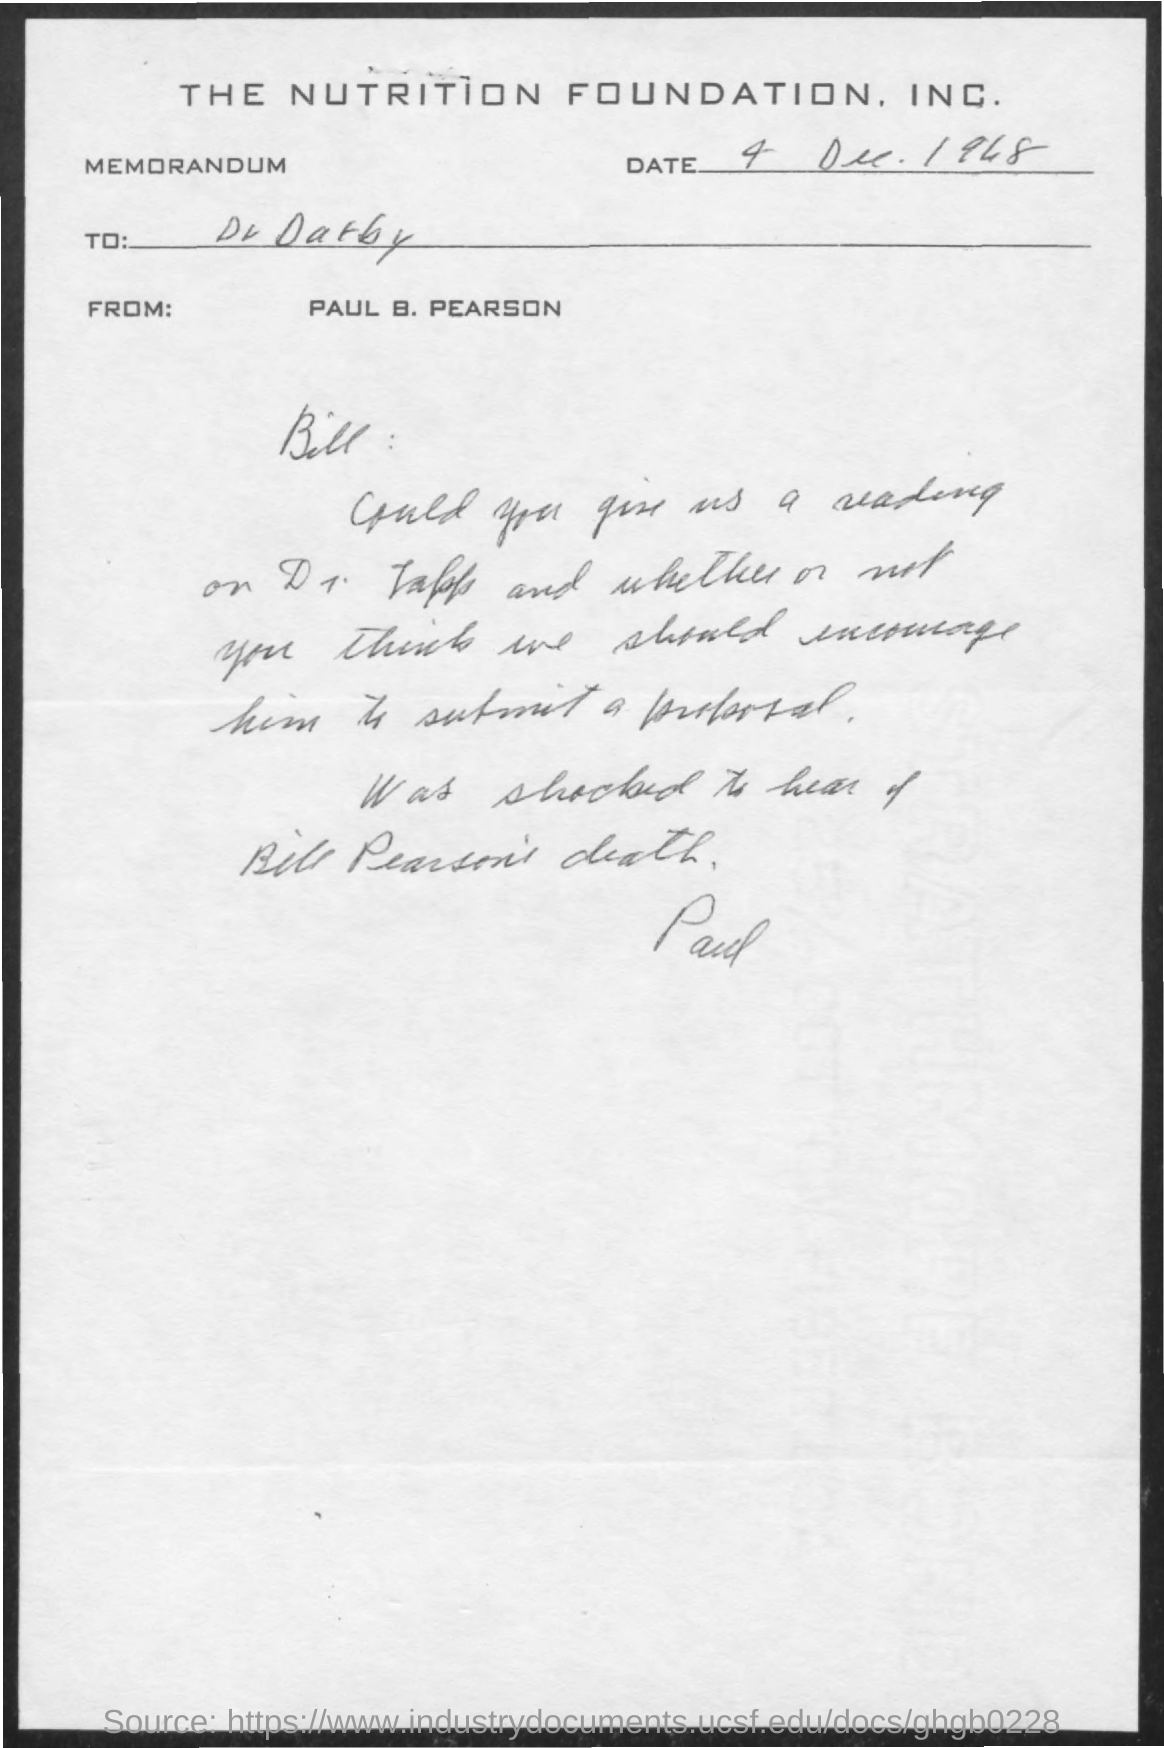Give some essential details in this illustration. The addressee of this memorandum is Bill. The date mentioned in the memorandum is December 4, 1948. The sender of this memorandum is Paul. This memorandum belongs to The Nutrition Foundation, Inc. 